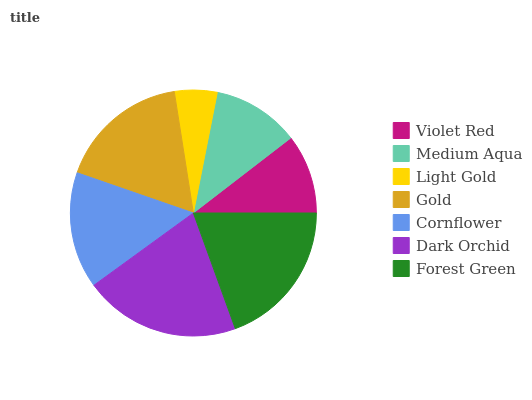Is Light Gold the minimum?
Answer yes or no. Yes. Is Dark Orchid the maximum?
Answer yes or no. Yes. Is Medium Aqua the minimum?
Answer yes or no. No. Is Medium Aqua the maximum?
Answer yes or no. No. Is Medium Aqua greater than Violet Red?
Answer yes or no. Yes. Is Violet Red less than Medium Aqua?
Answer yes or no. Yes. Is Violet Red greater than Medium Aqua?
Answer yes or no. No. Is Medium Aqua less than Violet Red?
Answer yes or no. No. Is Cornflower the high median?
Answer yes or no. Yes. Is Cornflower the low median?
Answer yes or no. Yes. Is Medium Aqua the high median?
Answer yes or no. No. Is Violet Red the low median?
Answer yes or no. No. 